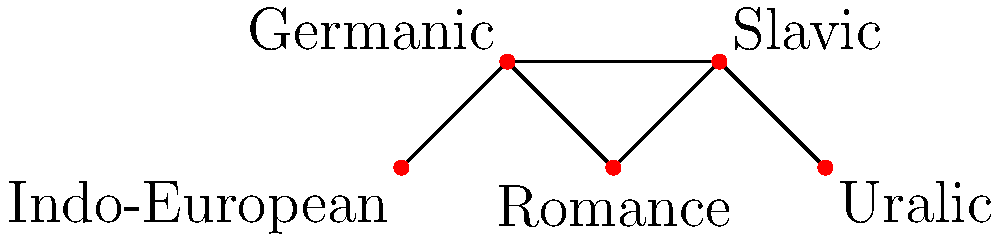In the graph representing language families, what is the minimum number of edges that need to be removed to disconnect the Indo-European language family from the Uralic language family? To answer this question, we need to analyze the connectivity of the graph:

1. Identify the nodes: Indo-European is the leftmost node, and Uralic is the rightmost node.

2. Examine the paths between these nodes:
   a. Indo-European → Germanic → Romance → Slavic → Uralic
   b. Indo-European → Germanic → Slavic → Uralic

3. Observe that both paths share the edge between Germanic and Slavic.

4. Removing this single edge (Germanic - Slavic) would disconnect all paths between Indo-European and Uralic.

5. There is no way to disconnect these language families by removing fewer than one edge.

Therefore, the minimum number of edges that need to be removed to disconnect the Indo-European language family from the Uralic language family is 1.
Answer: 1 